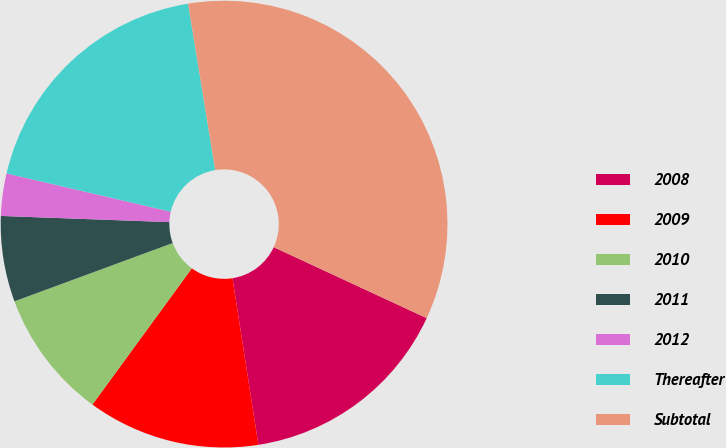<chart> <loc_0><loc_0><loc_500><loc_500><pie_chart><fcel>2008<fcel>2009<fcel>2010<fcel>2011<fcel>2012<fcel>Thereafter<fcel>Subtotal<nl><fcel>15.63%<fcel>12.49%<fcel>9.35%<fcel>6.2%<fcel>3.06%<fcel>18.78%<fcel>34.49%<nl></chart> 